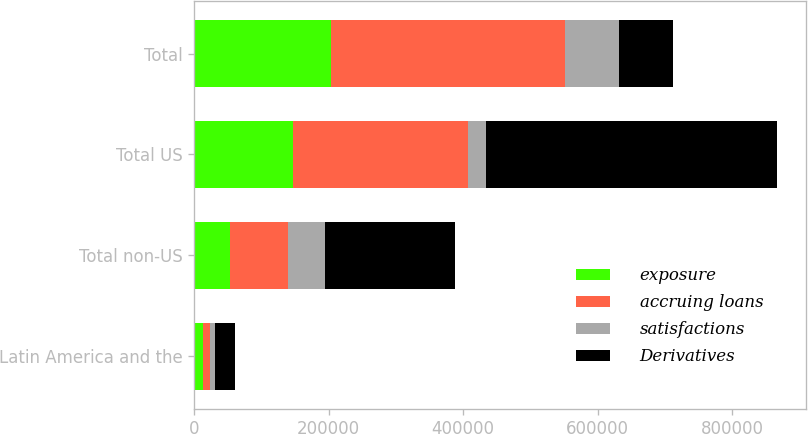<chart> <loc_0><loc_0><loc_500><loc_500><stacked_bar_chart><ecel><fcel>Latin America and the<fcel>Total non-US<fcel>Total US<fcel>Total<nl><fcel>exposure<fcel>13350<fcel>53617<fcel>146460<fcel>204175<nl><fcel>accruing loans<fcel>10249<fcel>85700<fcel>261455<fcel>347155<nl><fcel>satisfactions<fcel>6948<fcel>54610<fcel>25600<fcel>80210<nl><fcel>Derivatives<fcel>30547<fcel>193927<fcel>433515<fcel>80210<nl></chart> 